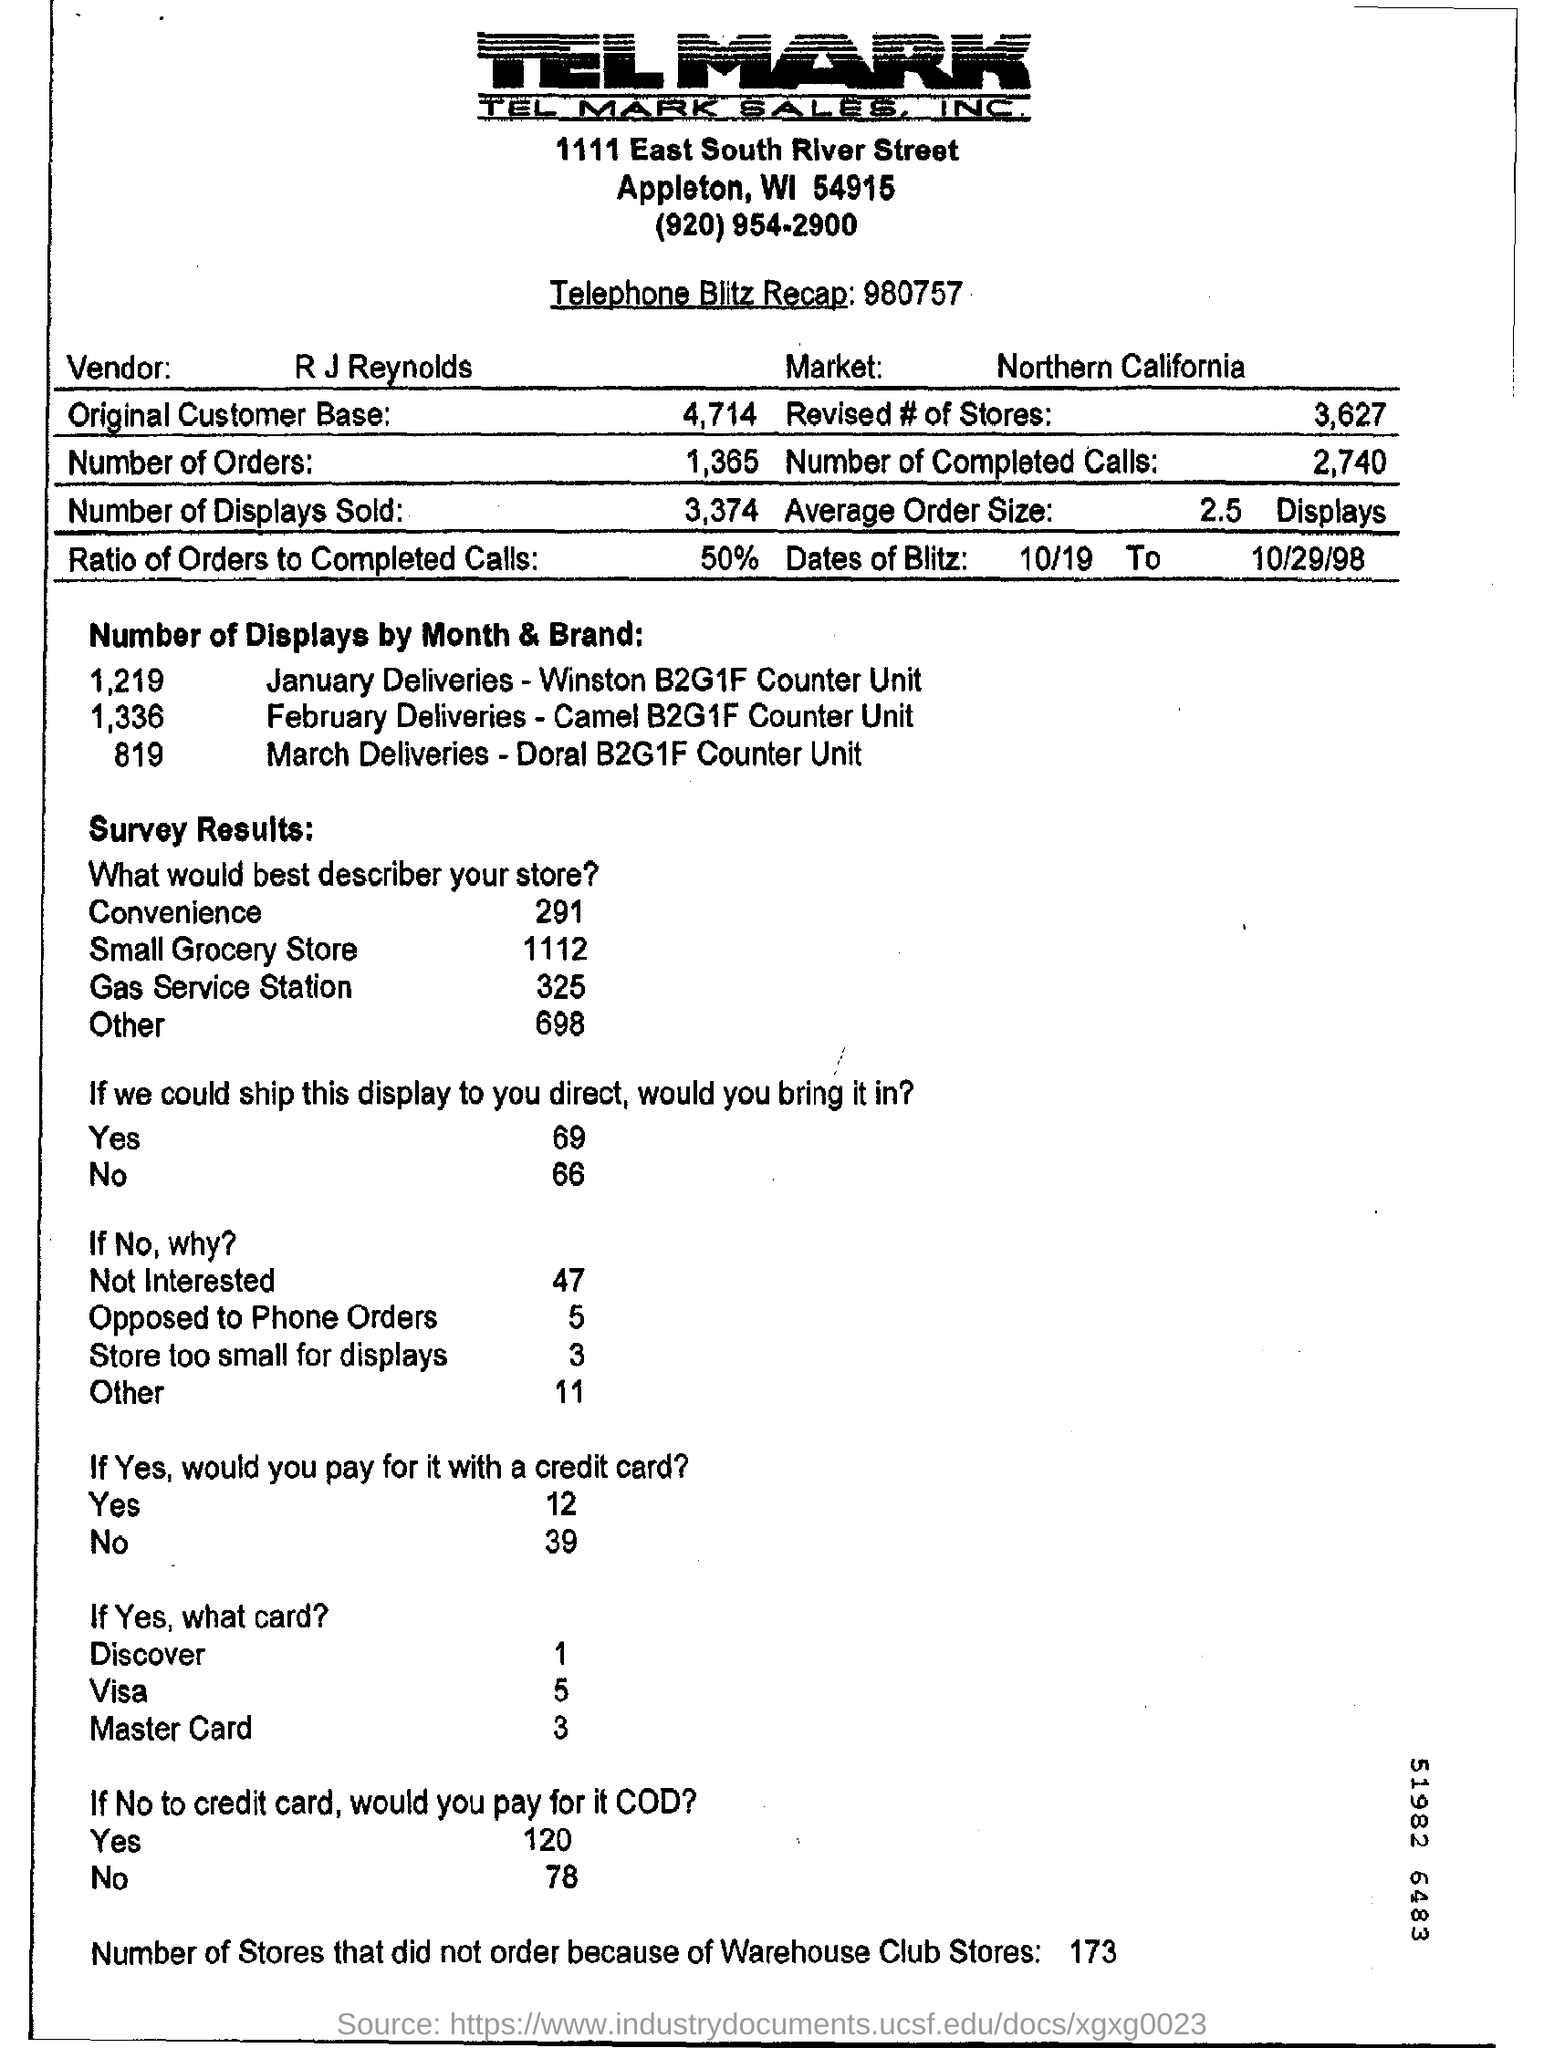Outline some significant characteristics in this image. Seventeen-three stores did not place orders due to warehouse club stores. The name of the market in Northern California is... There were 1365 orders in total. The ratio of orders to completed calls is 50%. The vendor's name is R.J. Reynolds. 